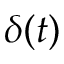Convert formula to latex. <formula><loc_0><loc_0><loc_500><loc_500>\delta ( t )</formula> 